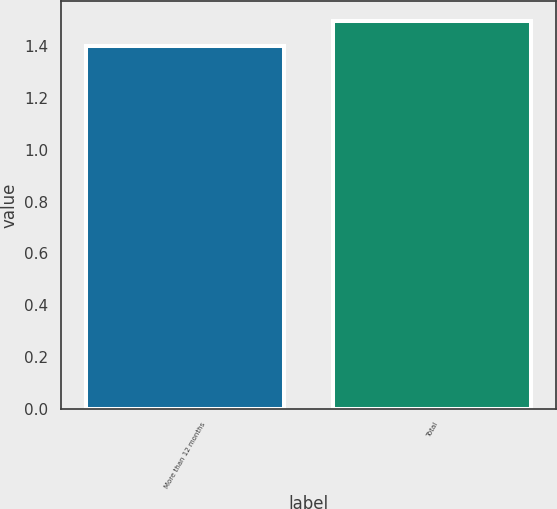Convert chart to OTSL. <chart><loc_0><loc_0><loc_500><loc_500><bar_chart><fcel>More than 12 months<fcel>Total<nl><fcel>1.4<fcel>1.5<nl></chart> 